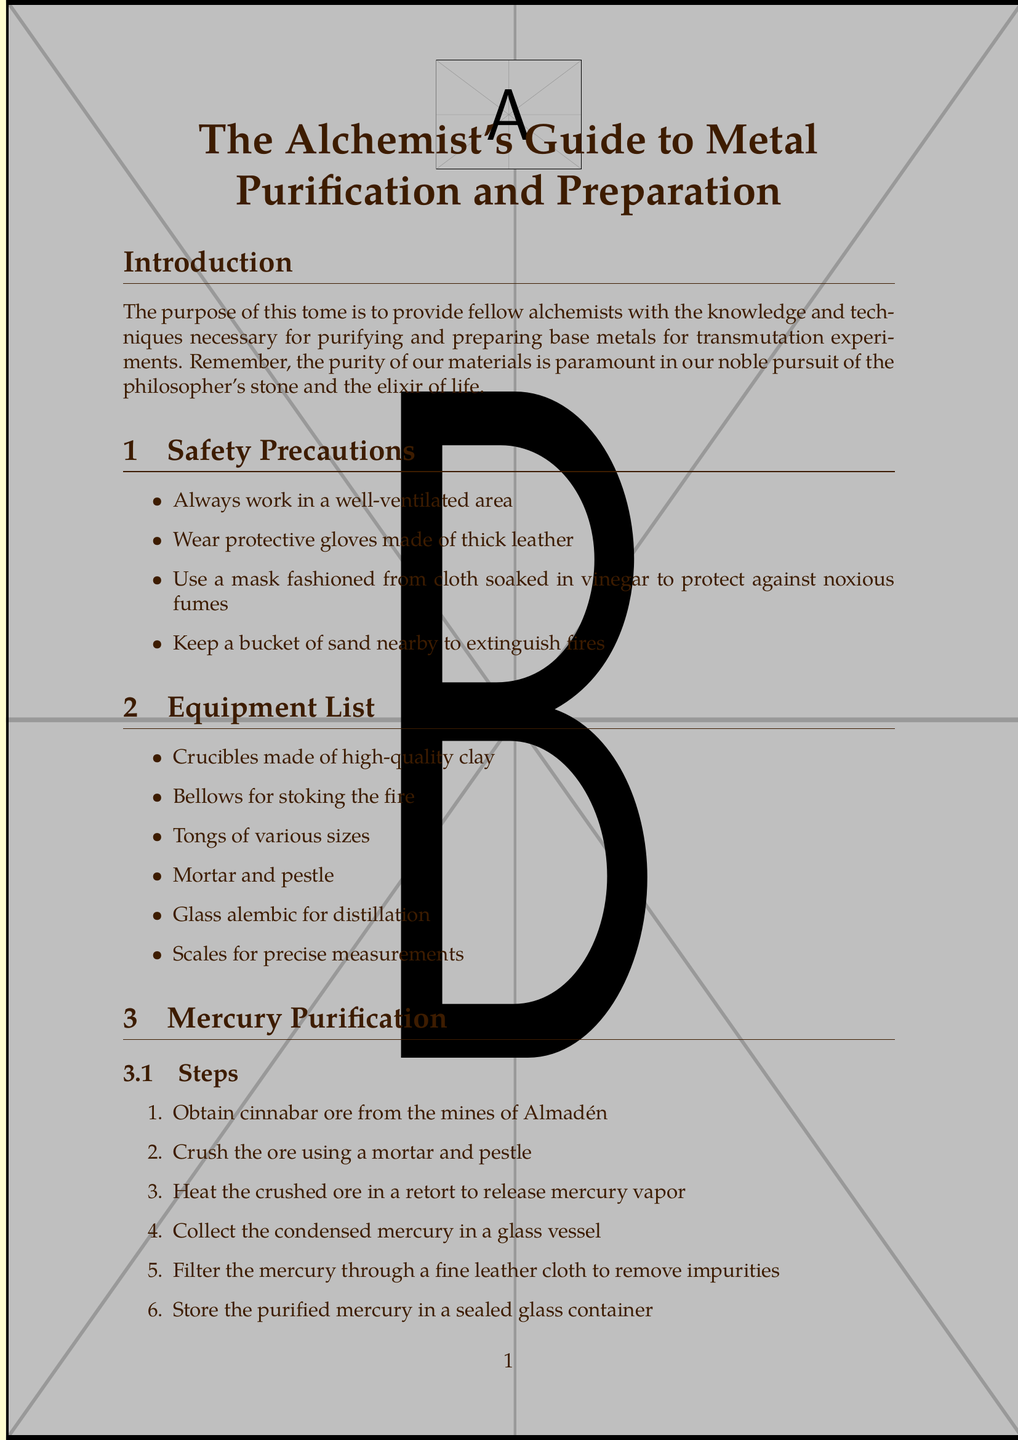What is the title of the manual? The title of the manual is stated at the beginning and serves as a reference for the entire document.
Answer: The Alchemist's Guide to Metal Purification and Preparation How many steps are involved in mercury purification? The document lists each step under the mercury purification section, providing specific procedures to follow.
Answer: Six steps What is the first step in lead preparation? The first step is clearly outlined in the lead preparation section, indicating the initial action required.
Answer: Acquire lead ore, preferably galena Which metal is associated with Venus? The section on copper refinement highlights the associations of the metal, including its astrological significance.
Answer: Copper What type of equipment is recommended for stoking the fire? The equipment list provides specific tools necessary for the purification and preparation processes mentioned.
Answer: Bellows What does the process of amalgamation involve? The document describes the amalgamation process and its application, along with an explanation of its significance.
Answer: Combining mercury with other metals How many safety precautions are listed? Counting the items in the safety precautions section gives an overview of the necessary measures to take.
Answer: Four precautions What does cupellation help purify? The advanced techniques section discusses cupellation and identifies the specific metals that can be purified using this method.
Answer: Gold and silver What philosophical consideration is mentioned? The section on philosophical considerations includes insightful reflections, emphasizing the relationship between metal purification and personal growth.
Answer: The purification of metals mirrors the purification of the soul 